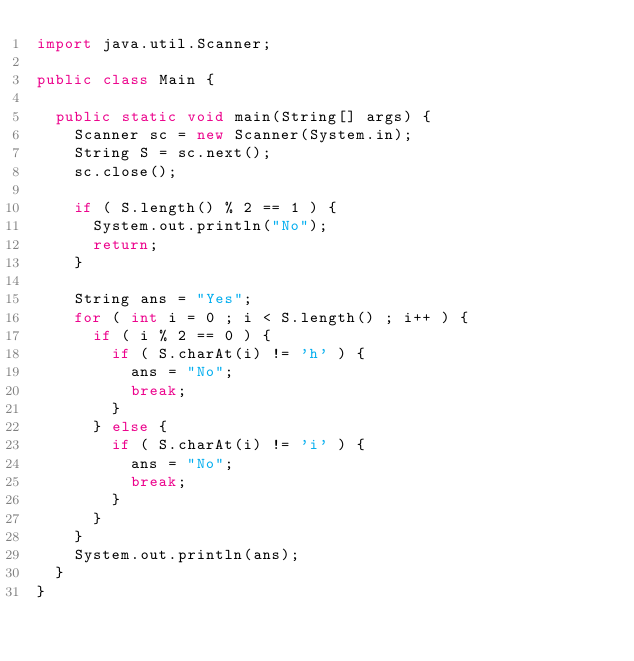Convert code to text. <code><loc_0><loc_0><loc_500><loc_500><_Java_>import java.util.Scanner;

public class Main {

	public static void main(String[] args) {
		Scanner sc = new Scanner(System.in);
		String S = sc.next();
		sc.close();

		if ( S.length() % 2 == 1 ) {
			System.out.println("No");
			return;
		}

		String ans = "Yes";
		for ( int i = 0 ; i < S.length() ; i++ ) {
			if ( i % 2 == 0 ) {
				if ( S.charAt(i) != 'h' ) {
					ans = "No";
					break;
				}
			} else {
				if ( S.charAt(i) != 'i' ) {
					ans = "No";
					break;
				}
			}
		}
		System.out.println(ans);
	}
}
</code> 